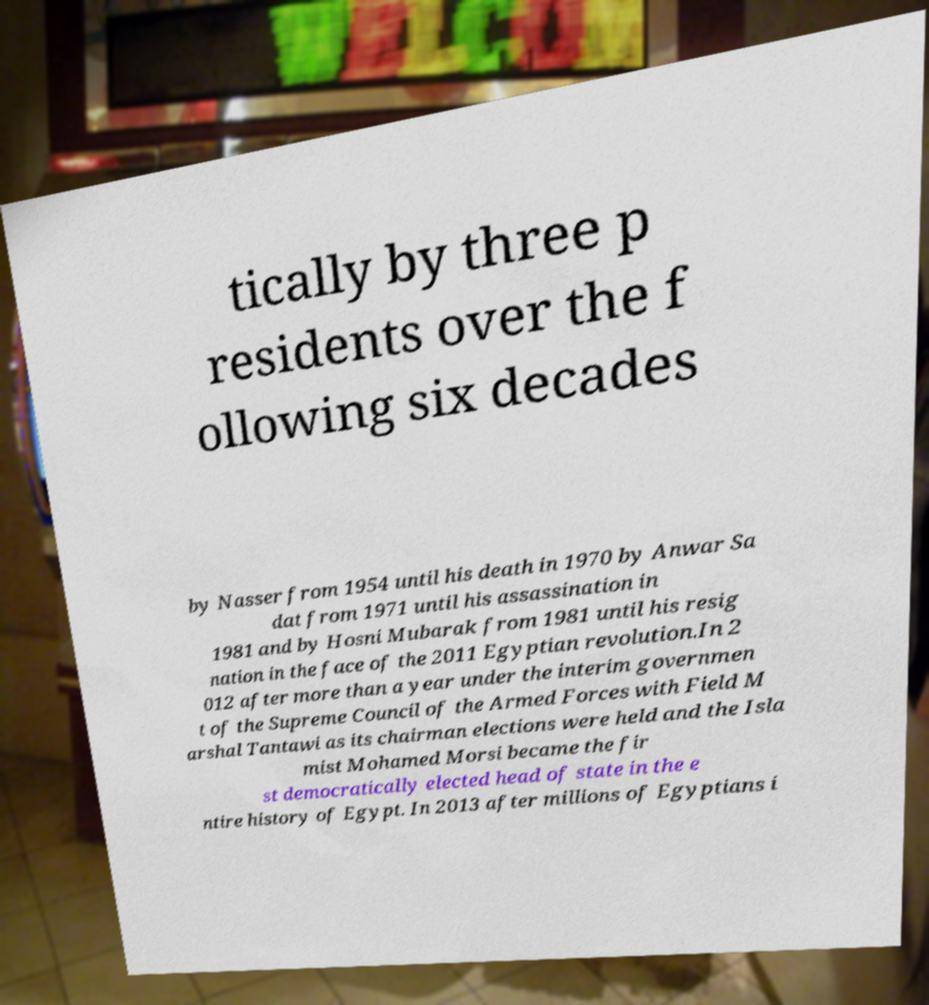Please read and relay the text visible in this image. What does it say? tically by three p residents over the f ollowing six decades by Nasser from 1954 until his death in 1970 by Anwar Sa dat from 1971 until his assassination in 1981 and by Hosni Mubarak from 1981 until his resig nation in the face of the 2011 Egyptian revolution.In 2 012 after more than a year under the interim governmen t of the Supreme Council of the Armed Forces with Field M arshal Tantawi as its chairman elections were held and the Isla mist Mohamed Morsi became the fir st democratically elected head of state in the e ntire history of Egypt. In 2013 after millions of Egyptians i 